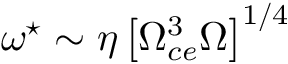Convert formula to latex. <formula><loc_0><loc_0><loc_500><loc_500>\omega ^ { ^ { * } } \sim \eta \left [ \Omega _ { c e } ^ { 3 } \Omega \right ] ^ { 1 / 4 }</formula> 